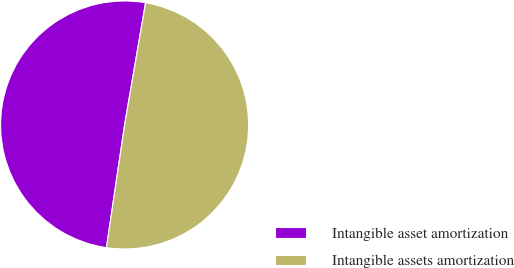<chart> <loc_0><loc_0><loc_500><loc_500><pie_chart><fcel>Intangible asset amortization<fcel>Intangible assets amortization<nl><fcel>50.37%<fcel>49.63%<nl></chart> 